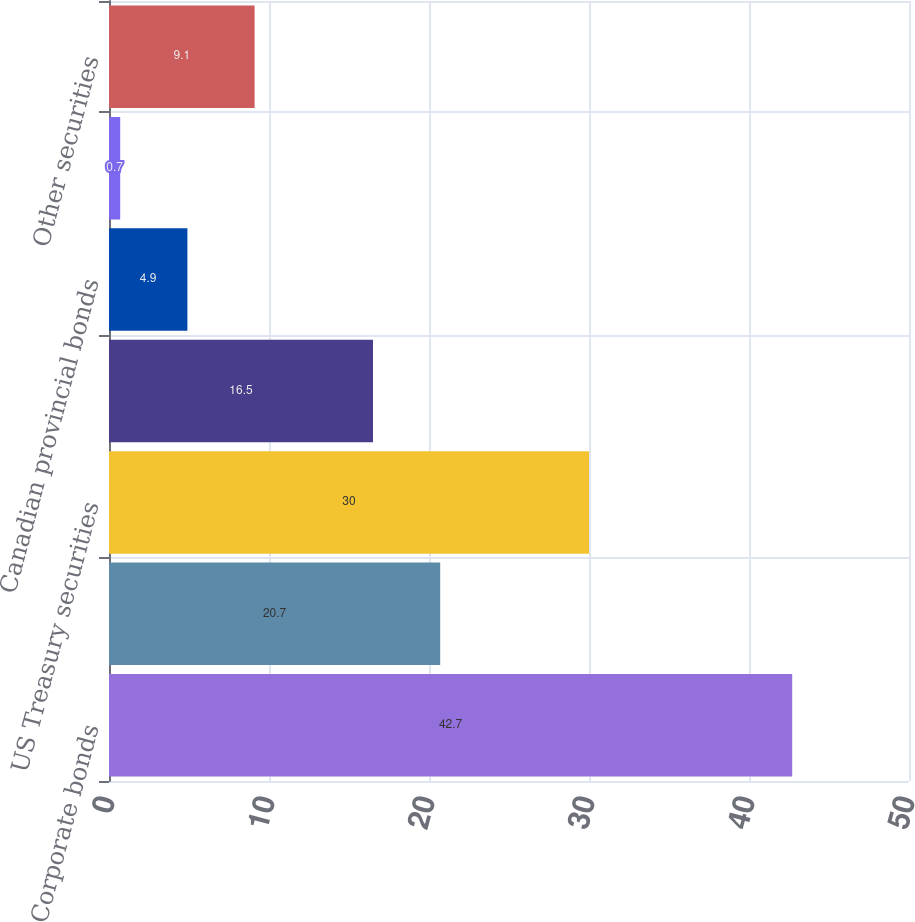<chart> <loc_0><loc_0><loc_500><loc_500><bar_chart><fcel>Corporate bonds<fcel>Asset-backed securities<fcel>US Treasury securities<fcel>US government agency<fcel>Canadian provincial bonds<fcel>Municipal bonds<fcel>Other securities<nl><fcel>42.7<fcel>20.7<fcel>30<fcel>16.5<fcel>4.9<fcel>0.7<fcel>9.1<nl></chart> 